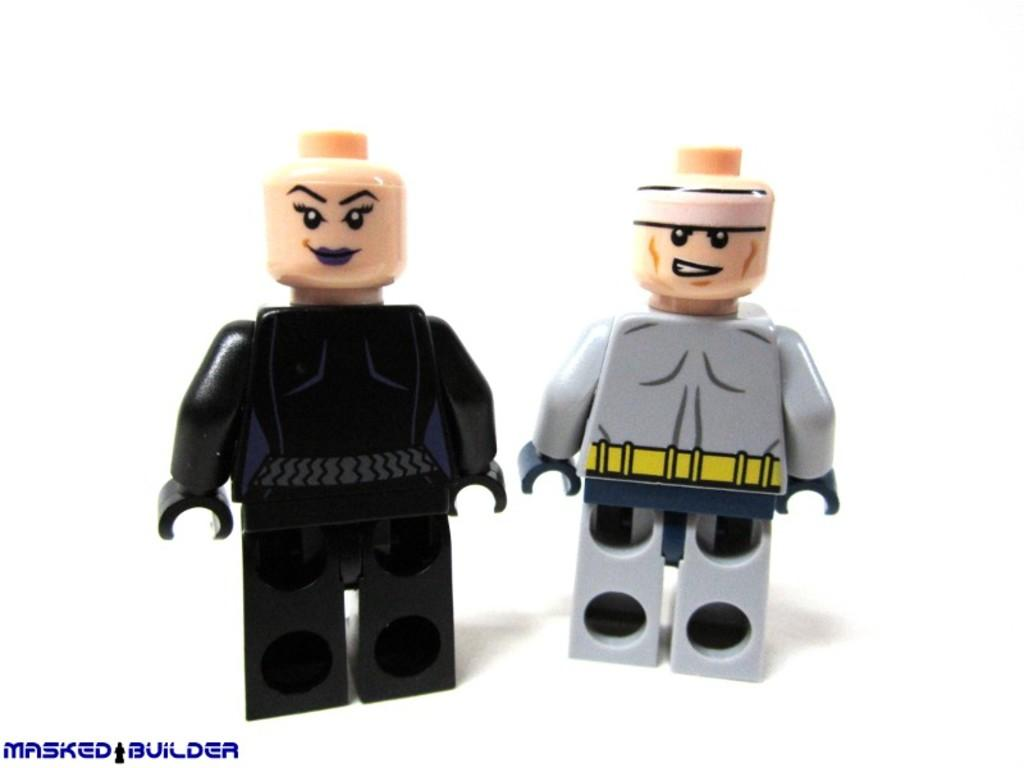How many dolls are present in the image? There are two men dolls in the image. What are the colors of the dolls? One doll is black in color, and the other doll is gray in color. What are the dolls wearing? Both dolls are wearing dresses. Reasoning: Let's think step by breaking down the facts to create the conversation. We start by identifying the number of dolls in the image, which is two. Then, we describe the colors of the dolls, mentioning that one is black and the other is gray. Finally, we focus on the clothing of the dolls, noting that both are wearing dresses. Each question is designed to provide specific details about the image based on the provided facts. Absurd Question/Answer: What type of quill is the black doll holding in the image? There is no quill present in the image; both dolls are wearing dresses. How many tomatoes are on the gray doll's dress in the image? There are no tomatoes present in the image; both dolls are wearing dresses without any visible tomatoes. 